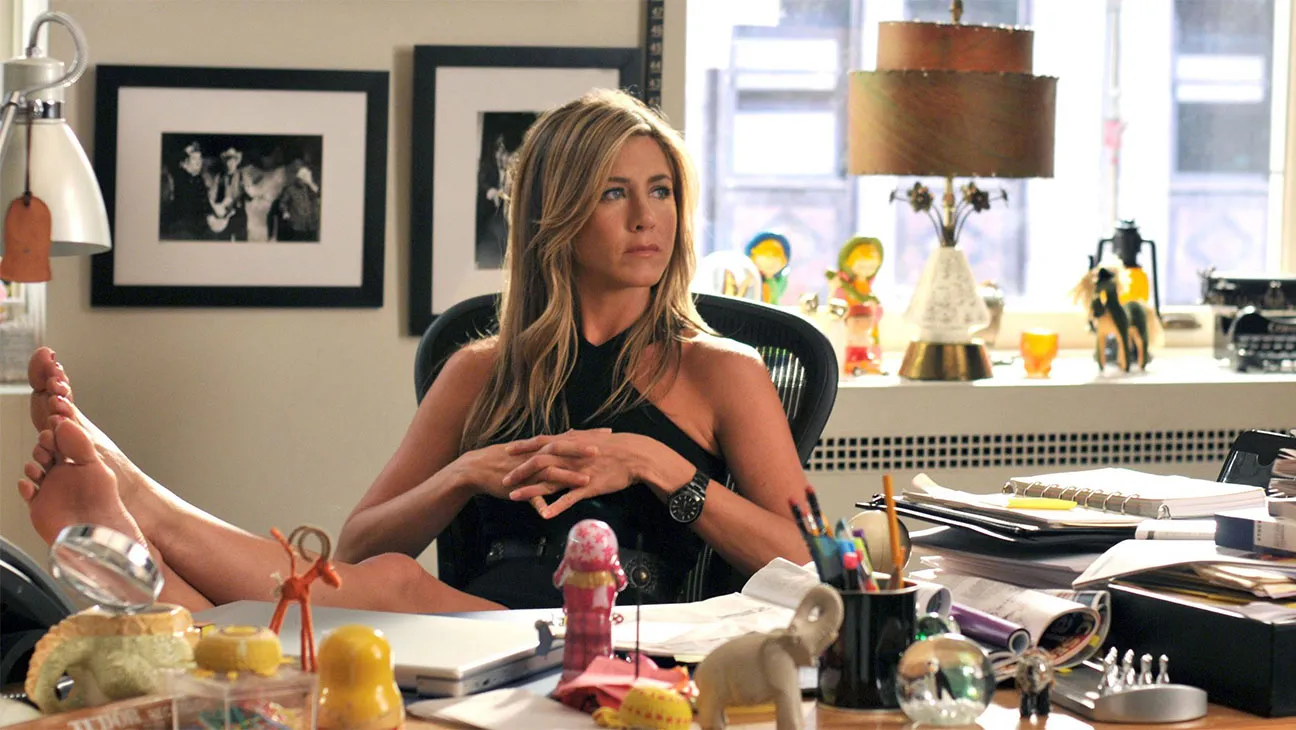How does the setting in the image contribute to the overall mood? The setting in the image, with its cluttered desk and personal items, creates a lived-in, authentic atmosphere that suggests the subject is in a space where work and personal life intersect. The relaxed posture of the subject along with the informal arrangement of items on the desk contributes to a casual, yet busy office environment. The natural light from the window also adds warmth, enhancing the contemplative mood of the scene. 